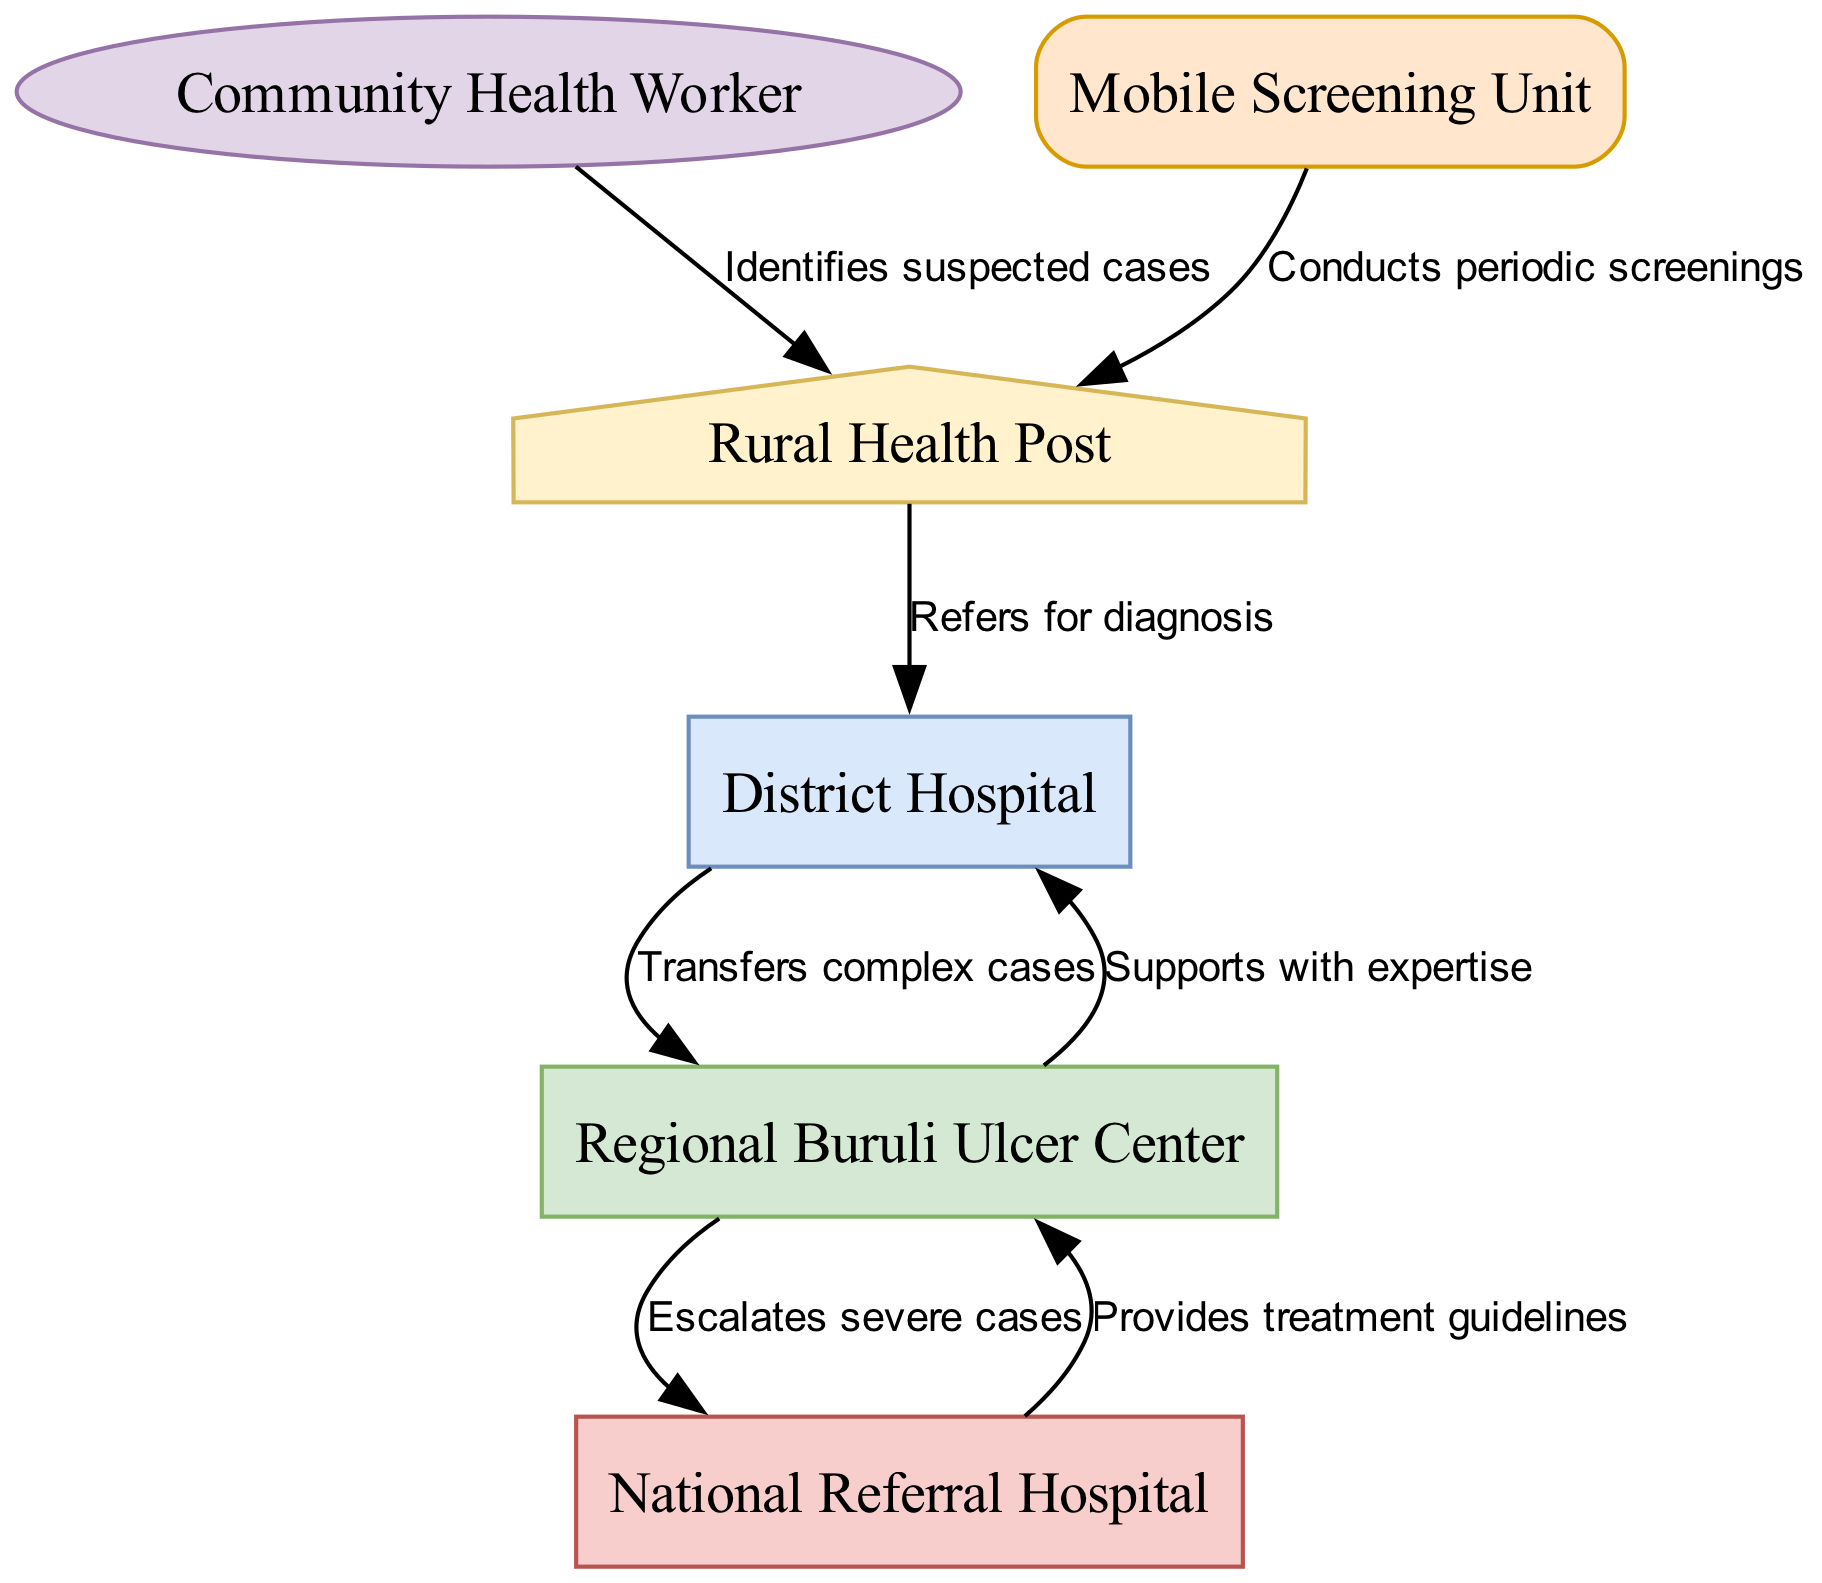What is the starting point for identifying suspected cases? The diagram indicates that the "Community Health Worker" is the first entity that identifies suspected cases of Buruli ulcer. This is the initial node that begins the referral process.
Answer: Community Health Worker How many nodes are present in the diagram? Counting the unique entities represented, there are six nodes in the diagram: Rural Health Post, District Hospital, Regional Buruli Ulcer Center, National Referral Hospital, Community Health Worker, and Mobile Screening Unit.
Answer: 6 What is the next step after a case is referred for diagnosis at the Rural Health Post? According to the diagram, once a case is referred for diagnosis at the Rural Health Post, it goes to the District Hospital. This is indicated by the directed edge labeled "Refers for diagnosis."
Answer: District Hospital Which entity escalates severe cases? The "Regional Buruli Ulcer Center" is responsible for escalating severe cases to the "National Referral Hospital" as shown by the directed edge labeled "Escalates severe cases."
Answer: Regional Buruli Ulcer Center What type of unit conducts periodic screenings before identifying cases? The diagram shows that the "Mobile Screening Unit" conducts periodic screenings, which help in identifying suspected cases that the Community Health Worker might later refer.
Answer: Mobile Screening Unit What support does the Regional Buruli Ulcer Center provide to the District Hospital? The diagram clearly indicates that the "Regional Buruli Ulcer Center" supports the "District Hospital" with expertise. This relationship is represented by the directed edge labeled "Supports with expertise."
Answer: Expertise What entity provides treatment guidelines to the Regional Buruli Ulcer Center? The "National Referral Hospital" provides treatment guidelines to the "Regional Buruli Ulcer Center" as indicated by the directed edge labeled "Provides treatment guidelines."
Answer: National Referral Hospital How many edges are there in the diagram? The diagram includes a total of six edges that represent the relationships and referral processes between the nodes, detailing how one entity interacts with another.
Answer: 6 Which node is the final step in the treatment process for severe cases? The "National Referral Hospital" is the final entity for the treatment of severe cases, as it receives cases escalated from the Regional Buruli Ulcer Center.
Answer: National Referral Hospital 